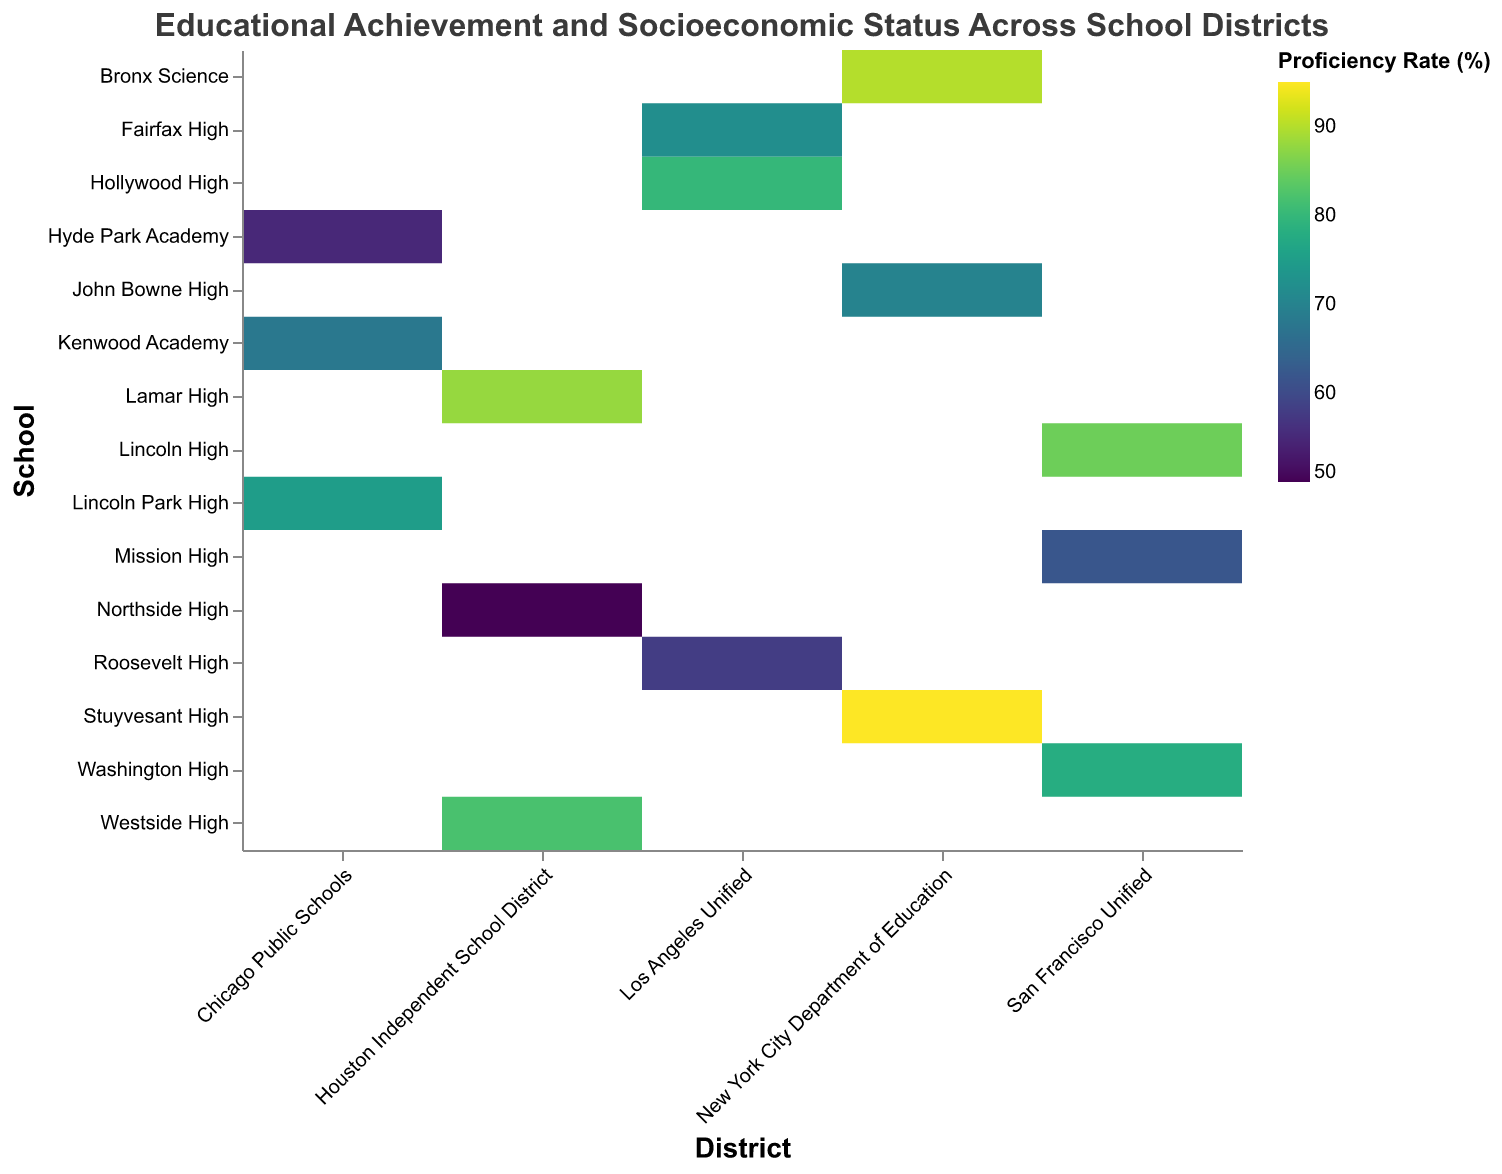What is the title of the heatmap? The title is usually located at the top of the figure. In this heatmap, the title reads, "Educational Achievement and Socioeconomic Status Across School Districts".
Answer: Educational Achievement and Socioeconomic Status Across School Districts Which school has the highest proficiency rate? By examining the color intensities on the heatmap, the school with the deepest color, corresponding to the highest proficiency rate, is Stuyvesant High.
Answer: Stuyvesant High Which Houston Independent School District school has the lowest proficiency rate? Look at the colors associated with the Houston Independent School District schools. Northside High has the lightest color indicating the lowest proficiency rate.
Answer: Northside High What are the factors displayed in the tooltip? When you hover over a cell in a heatmap, the tooltip usually provides detailed information. Here, it shows District, School, Proficiency Rate (%), and Average SES (Socioeconomic Status).
Answer: District, School, Proficiency Rate (%), Average SES (Socioeconomic Status) Which district has the highest average proficiency rate across its schools? To determine this, consider the average of the proficiency rates for each district's schools. New York City Department of Education (90, 95, 70) has an average of (90 + 95 + 70)/3 = 85, which is the highest.
Answer: New York City Department of Education Compare Lincoln High and Mission High in the San Francisco Unified district in terms of proficiency rate and average SES. Refer to the heatmap to identify the specific values. Lincoln High has a proficiency rate of 85% and an SES of 0.75, while Mission High has a proficiency rate of 62% and an SES of 0.45. Lincoln High has both higher proficiency and SES.
Answer: Lincoln High has higher proficiency and SES Is there a correlation between proficiency rate and average SES for the schools in the heatmap? By analyzing the heatmap, you will notice that generally, higher SES values correspond to higher proficiency rates, indicating a positive correlation.
Answer: Positive correlation Which two schools in the same district have the largest difference in proficiency rates? Compare the proficiency rates within each district. In the New York City Department of Education, the largest difference is between Stuyvesant High (95%) and John Bowne High (70%), with a difference of 25 percentage points.
Answer: Stuyvesant High and John Bowne High If you were to rank all the schools by proficiency rate, which school would be in the middle (the median)? List all the proficiency rates in ascending order: 50, 55, 58, 62, 68, 70, 72, 75, 78, 80, 82, 85, 88, 90, 95. The median proficiency rate is the 8th value, which is 75. Therefore, Lincoln Park High is the median school.
Answer: Lincoln Park High 